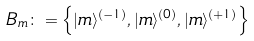Convert formula to latex. <formula><loc_0><loc_0><loc_500><loc_500>B _ { m } \colon = \left \{ | m \rangle ^ { ( - 1 ) } , | m \rangle ^ { ( 0 ) } , | m \rangle ^ { ( + 1 ) } \right \}</formula> 